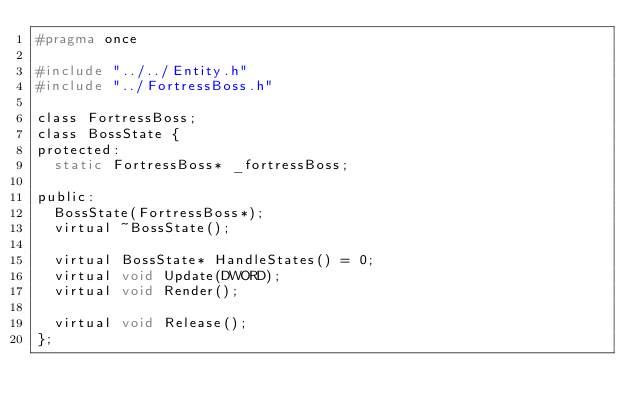<code> <loc_0><loc_0><loc_500><loc_500><_C_>#pragma once

#include "../../Entity.h"
#include "../FortressBoss.h"

class FortressBoss;
class BossState {
protected:
	static FortressBoss* _fortressBoss;

public:
	BossState(FortressBoss*);
	virtual ~BossState();

	virtual BossState* HandleStates() = 0;
	virtual void Update(DWORD);
	virtual void Render();

	virtual void Release();
};</code> 